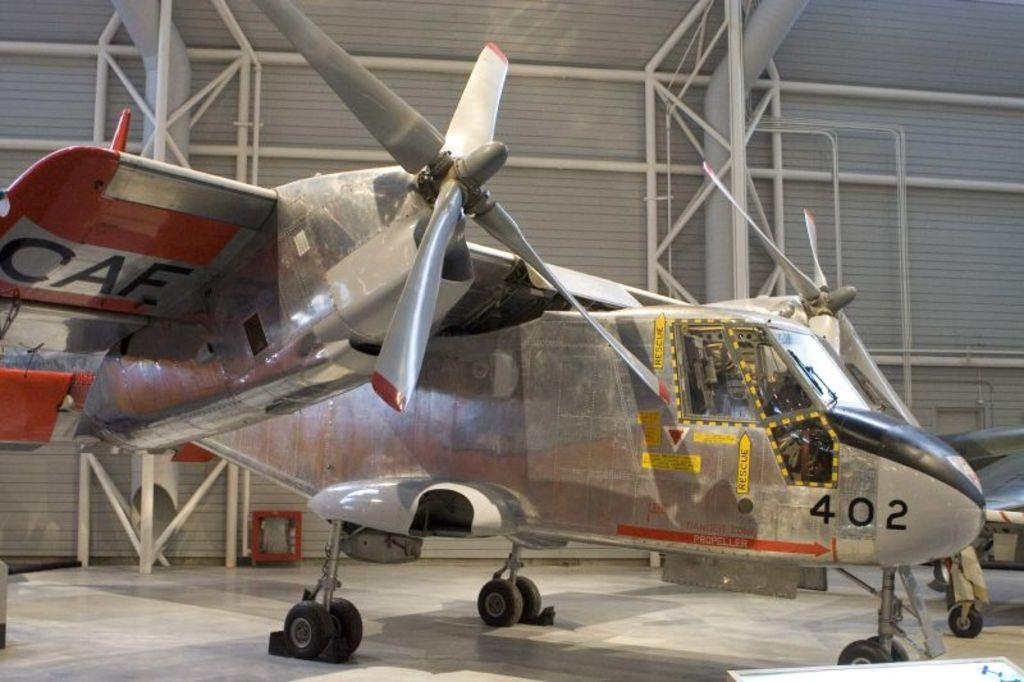<image>
Give a short and clear explanation of the subsequent image. An old metal airplane sits in a wharehouse on display with the number 402 written on the side 